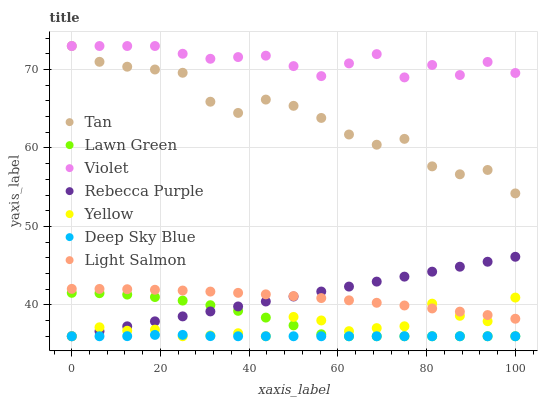Does Deep Sky Blue have the minimum area under the curve?
Answer yes or no. Yes. Does Violet have the maximum area under the curve?
Answer yes or no. Yes. Does Light Salmon have the minimum area under the curve?
Answer yes or no. No. Does Light Salmon have the maximum area under the curve?
Answer yes or no. No. Is Rebecca Purple the smoothest?
Answer yes or no. Yes. Is Tan the roughest?
Answer yes or no. Yes. Is Light Salmon the smoothest?
Answer yes or no. No. Is Light Salmon the roughest?
Answer yes or no. No. Does Lawn Green have the lowest value?
Answer yes or no. Yes. Does Light Salmon have the lowest value?
Answer yes or no. No. Does Tan have the highest value?
Answer yes or no. Yes. Does Light Salmon have the highest value?
Answer yes or no. No. Is Yellow less than Tan?
Answer yes or no. Yes. Is Tan greater than Rebecca Purple?
Answer yes or no. Yes. Does Rebecca Purple intersect Lawn Green?
Answer yes or no. Yes. Is Rebecca Purple less than Lawn Green?
Answer yes or no. No. Is Rebecca Purple greater than Lawn Green?
Answer yes or no. No. Does Yellow intersect Tan?
Answer yes or no. No. 